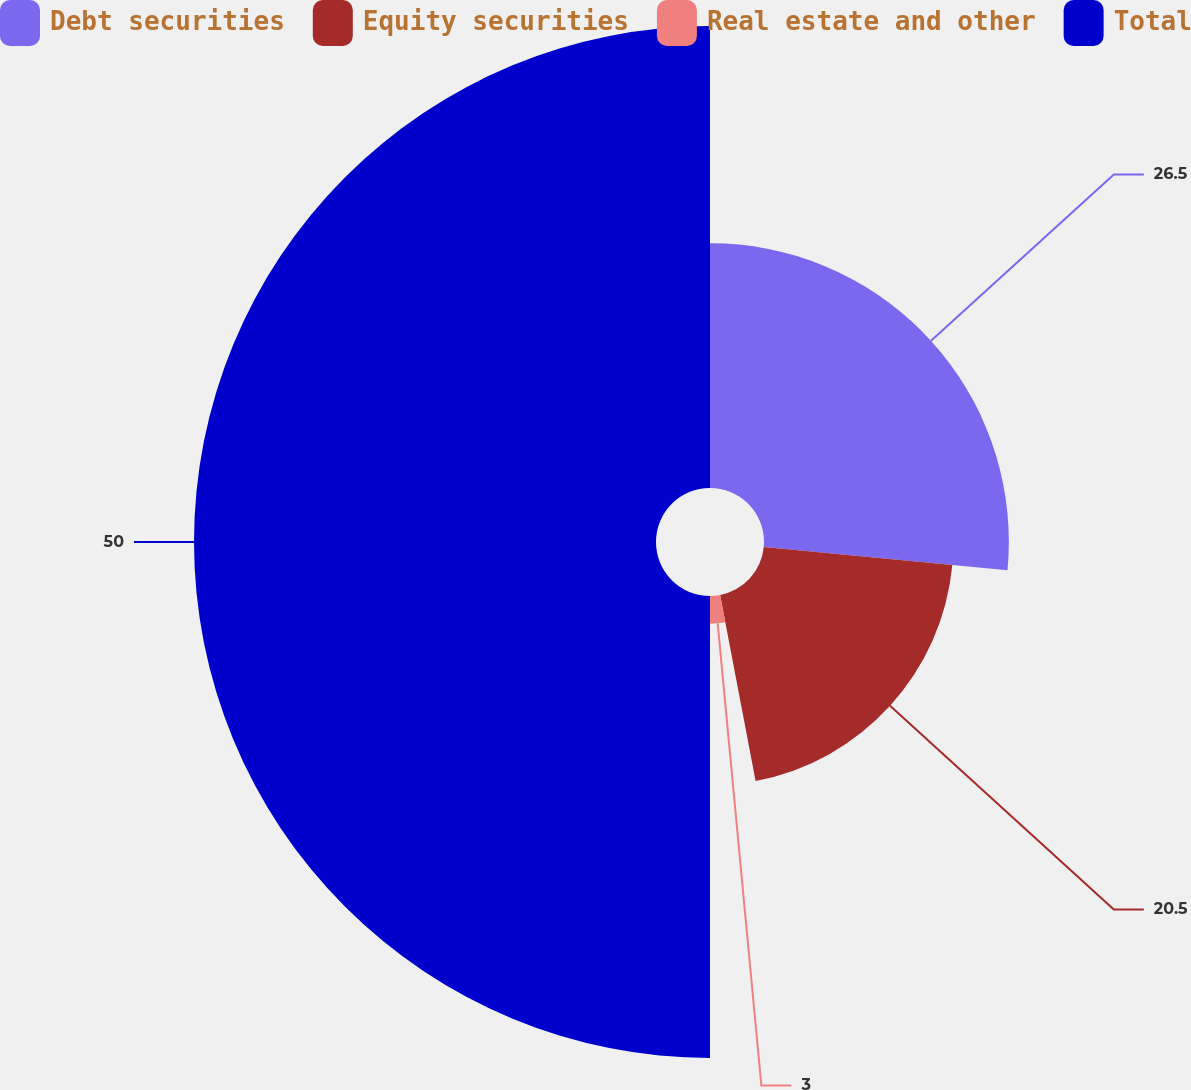Convert chart. <chart><loc_0><loc_0><loc_500><loc_500><pie_chart><fcel>Debt securities<fcel>Equity securities<fcel>Real estate and other<fcel>Total<nl><fcel>26.5%<fcel>20.5%<fcel>3.0%<fcel>50.0%<nl></chart> 